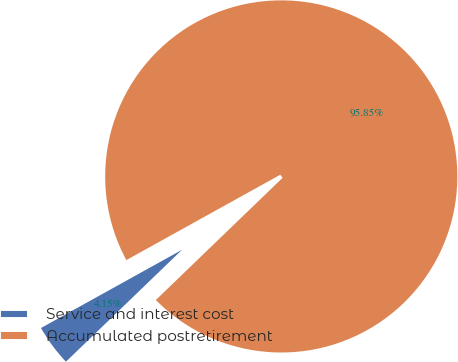Convert chart. <chart><loc_0><loc_0><loc_500><loc_500><pie_chart><fcel>Service and interest cost<fcel>Accumulated postretirement<nl><fcel>4.15%<fcel>95.85%<nl></chart> 